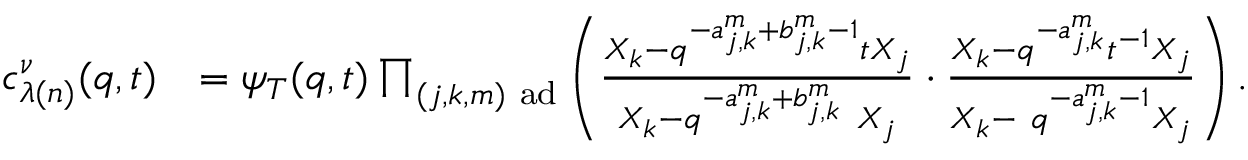Convert formula to latex. <formula><loc_0><loc_0><loc_500><loc_500>\begin{array} { r l } { c _ { \lambda ( n ) } ^ { \nu } ( q , t ) } & { = \psi _ { T } ( q , t ) \prod _ { ( j , k , m ) a d } \left ( \frac { X _ { k } - q ^ { - a _ { j , k } ^ { m } + b _ { j , k } ^ { m } - 1 } t X _ { j } } { X _ { k } - q ^ { - a _ { j , k } ^ { m } + b _ { j , k } ^ { m } } \ X _ { j } } \cdot \frac { X _ { k } - q ^ { - a _ { j , k } ^ { m } } t ^ { - 1 } X _ { j } } { X _ { k } - \ q ^ { - a _ { j , k } ^ { m } - 1 } X _ { j } } \right ) . } \end{array}</formula> 